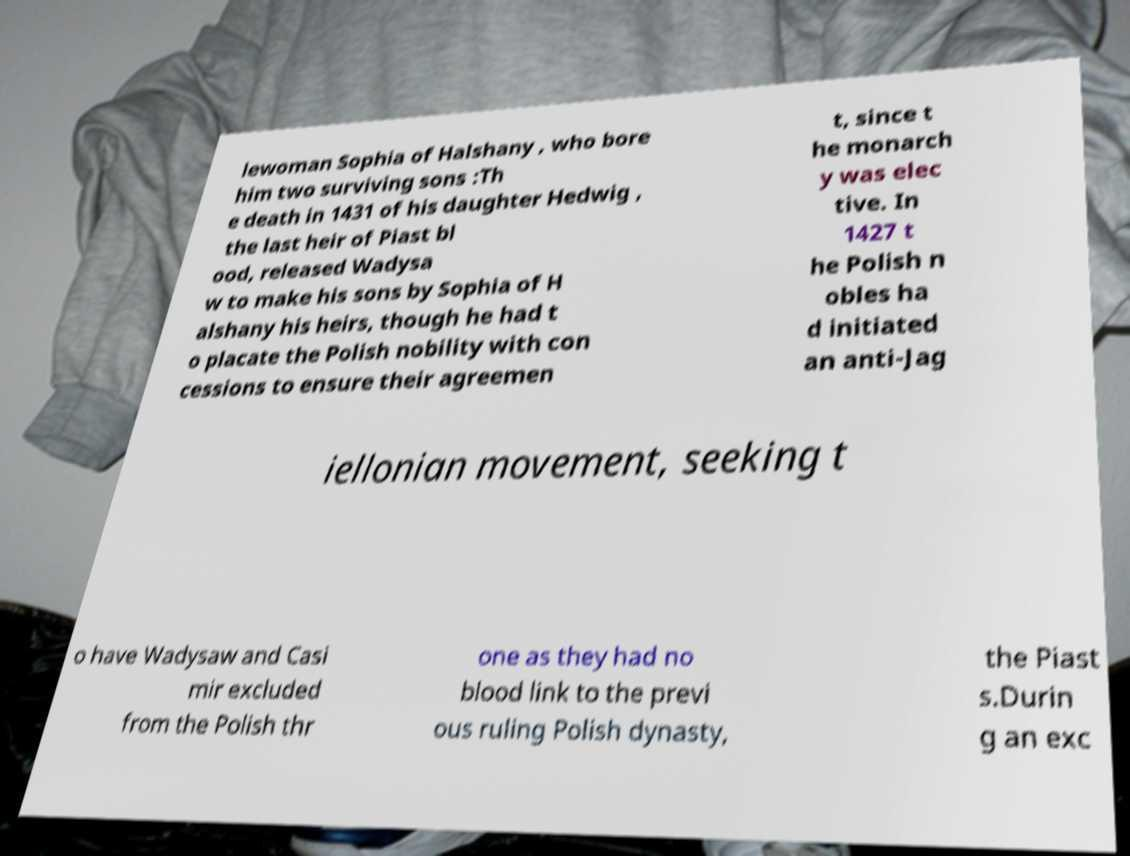I need the written content from this picture converted into text. Can you do that? lewoman Sophia of Halshany , who bore him two surviving sons :Th e death in 1431 of his daughter Hedwig , the last heir of Piast bl ood, released Wadysa w to make his sons by Sophia of H alshany his heirs, though he had t o placate the Polish nobility with con cessions to ensure their agreemen t, since t he monarch y was elec tive. In 1427 t he Polish n obles ha d initiated an anti-Jag iellonian movement, seeking t o have Wadysaw and Casi mir excluded from the Polish thr one as they had no blood link to the previ ous ruling Polish dynasty, the Piast s.Durin g an exc 